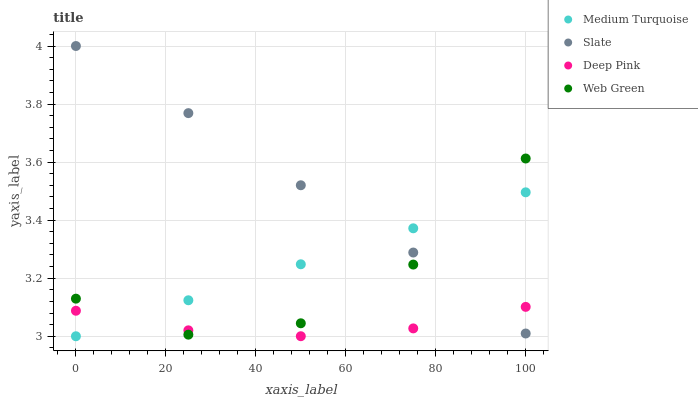Does Deep Pink have the minimum area under the curve?
Answer yes or no. Yes. Does Slate have the maximum area under the curve?
Answer yes or no. Yes. Does Web Green have the minimum area under the curve?
Answer yes or no. No. Does Web Green have the maximum area under the curve?
Answer yes or no. No. Is Medium Turquoise the smoothest?
Answer yes or no. Yes. Is Web Green the roughest?
Answer yes or no. Yes. Is Deep Pink the smoothest?
Answer yes or no. No. Is Deep Pink the roughest?
Answer yes or no. No. Does Medium Turquoise have the lowest value?
Answer yes or no. Yes. Does Deep Pink have the lowest value?
Answer yes or no. No. Does Slate have the highest value?
Answer yes or no. Yes. Does Web Green have the highest value?
Answer yes or no. No. Does Web Green intersect Medium Turquoise?
Answer yes or no. Yes. Is Web Green less than Medium Turquoise?
Answer yes or no. No. Is Web Green greater than Medium Turquoise?
Answer yes or no. No. 